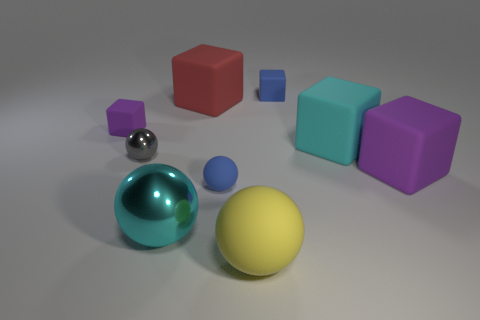There is a purple object in front of the tiny matte cube that is left of the tiny blue rubber object right of the blue ball; how big is it?
Your response must be concise. Large. The small cube that is on the left side of the tiny object that is to the right of the big yellow object is what color?
Give a very brief answer. Purple. How many other things are made of the same material as the small purple cube?
Your answer should be very brief. 6. What number of other things are the same color as the tiny rubber sphere?
Provide a succinct answer. 1. What is the big cyan object in front of the small gray shiny object to the left of the red cube made of?
Your answer should be very brief. Metal. Are there any gray matte things?
Provide a succinct answer. No. What is the size of the blue rubber thing that is in front of the tiny rubber thing right of the large rubber sphere?
Provide a succinct answer. Small. Are there more big purple cubes that are to the right of the large purple rubber thing than big red rubber blocks in front of the large rubber sphere?
Your response must be concise. No. How many balls are either big things or large shiny things?
Make the answer very short. 2. Does the matte object that is in front of the small blue sphere have the same shape as the big red rubber object?
Offer a terse response. No. 